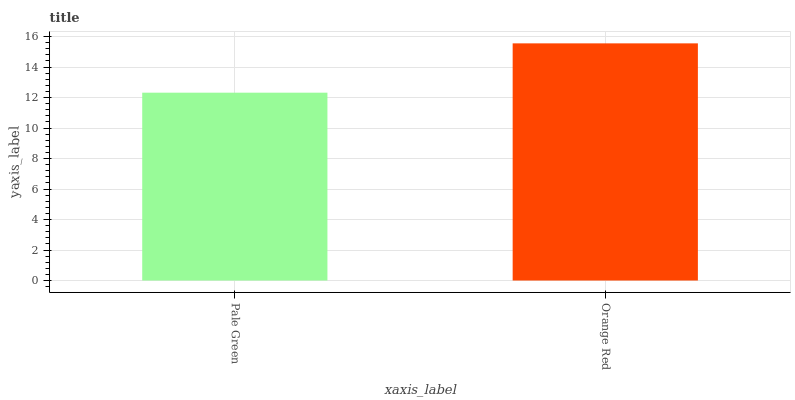Is Pale Green the minimum?
Answer yes or no. Yes. Is Orange Red the maximum?
Answer yes or no. Yes. Is Orange Red the minimum?
Answer yes or no. No. Is Orange Red greater than Pale Green?
Answer yes or no. Yes. Is Pale Green less than Orange Red?
Answer yes or no. Yes. Is Pale Green greater than Orange Red?
Answer yes or no. No. Is Orange Red less than Pale Green?
Answer yes or no. No. Is Orange Red the high median?
Answer yes or no. Yes. Is Pale Green the low median?
Answer yes or no. Yes. Is Pale Green the high median?
Answer yes or no. No. Is Orange Red the low median?
Answer yes or no. No. 